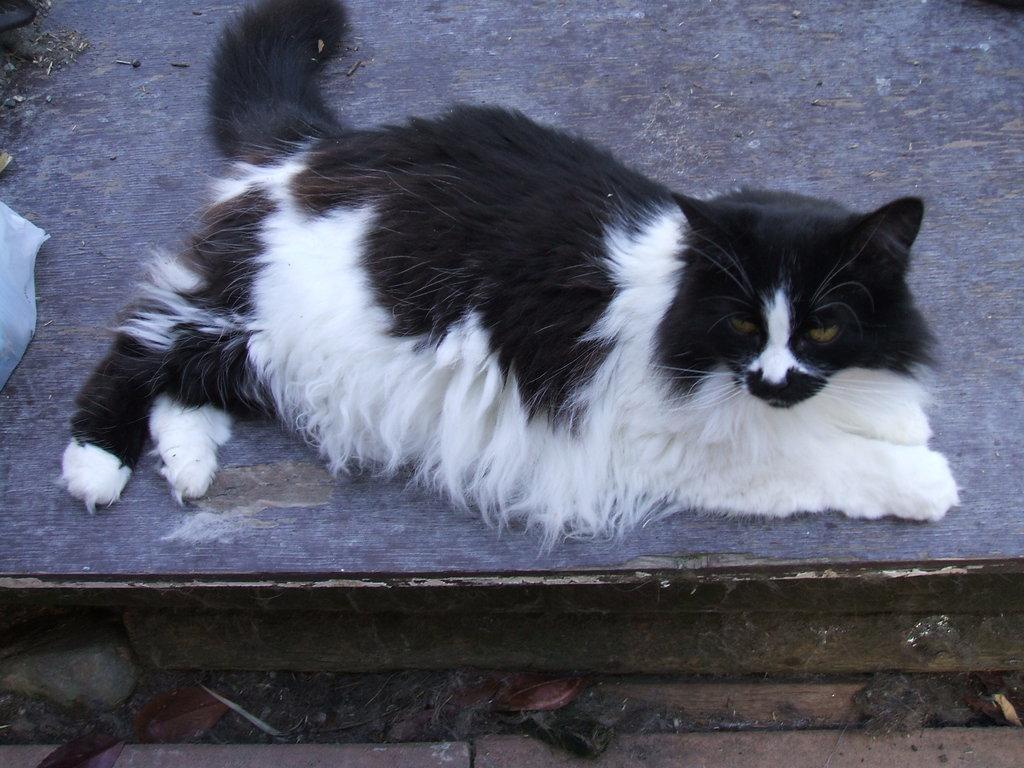Please provide a concise description of this image. In this image we can see a cat on the wooden surface. 